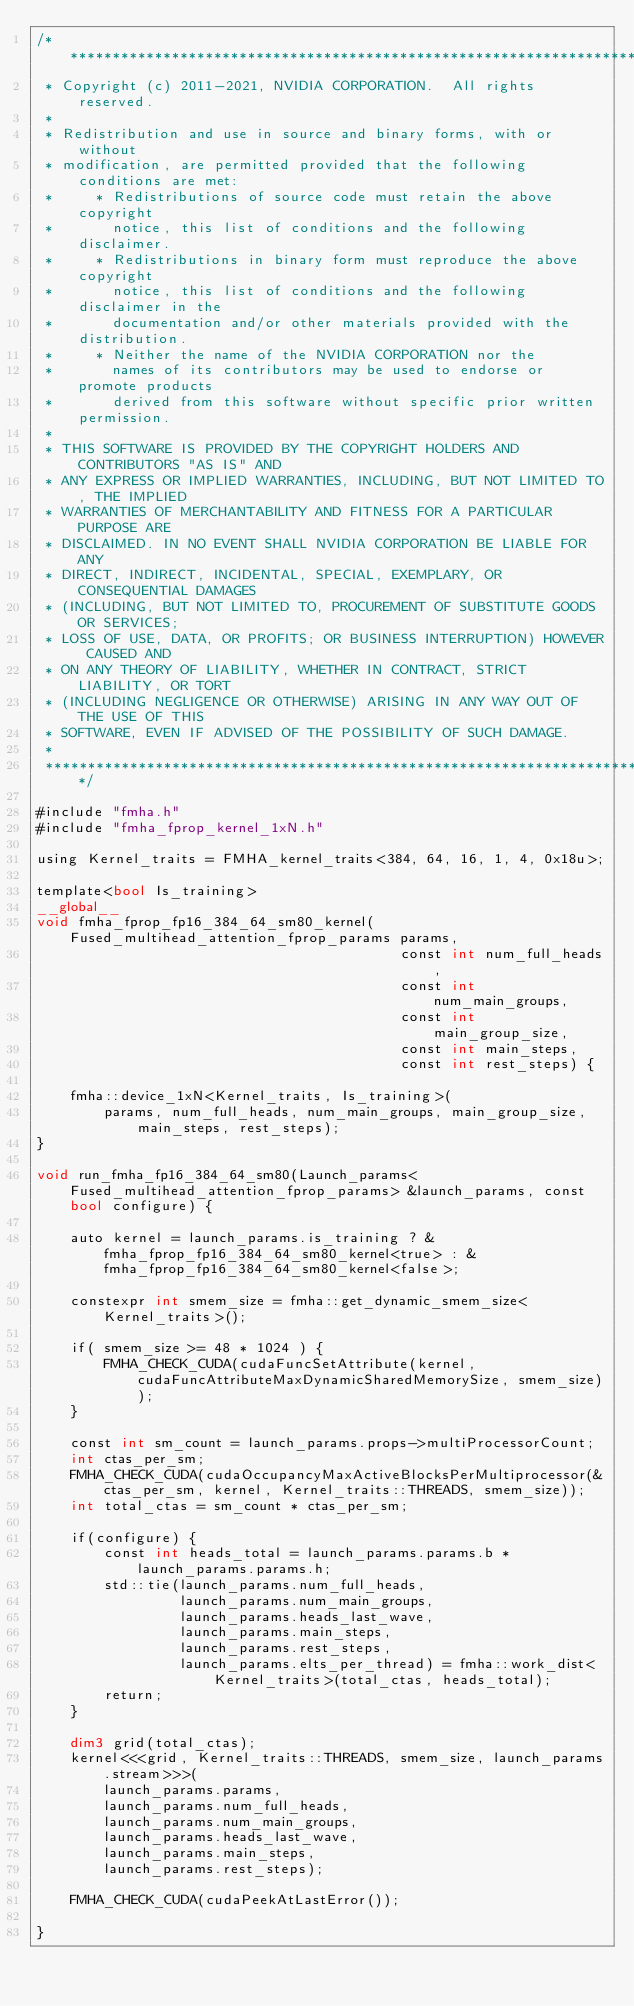Convert code to text. <code><loc_0><loc_0><loc_500><loc_500><_Cuda_>/******************************************************************************
 * Copyright (c) 2011-2021, NVIDIA CORPORATION.  All rights reserved.
 * 
 * Redistribution and use in source and binary forms, with or without
 * modification, are permitted provided that the following conditions are met:
 *     * Redistributions of source code must retain the above copyright
 *       notice, this list of conditions and the following disclaimer.
 *     * Redistributions in binary form must reproduce the above copyright
 *       notice, this list of conditions and the following disclaimer in the
 *       documentation and/or other materials provided with the distribution.
 *     * Neither the name of the NVIDIA CORPORATION nor the
 *       names of its contributors may be used to endorse or promote products
 *       derived from this software without specific prior written permission.
 * 
 * THIS SOFTWARE IS PROVIDED BY THE COPYRIGHT HOLDERS AND CONTRIBUTORS "AS IS" AND
 * ANY EXPRESS OR IMPLIED WARRANTIES, INCLUDING, BUT NOT LIMITED TO, THE IMPLIED
 * WARRANTIES OF MERCHANTABILITY AND FITNESS FOR A PARTICULAR PURPOSE ARE
 * DISCLAIMED. IN NO EVENT SHALL NVIDIA CORPORATION BE LIABLE FOR ANY
 * DIRECT, INDIRECT, INCIDENTAL, SPECIAL, EXEMPLARY, OR CONSEQUENTIAL DAMAGES
 * (INCLUDING, BUT NOT LIMITED TO, PROCUREMENT OF SUBSTITUTE GOODS OR SERVICES;
 * LOSS OF USE, DATA, OR PROFITS; OR BUSINESS INTERRUPTION) HOWEVER CAUSED AND
 * ON ANY THEORY OF LIABILITY, WHETHER IN CONTRACT, STRICT LIABILITY, OR TORT
 * (INCLUDING NEGLIGENCE OR OTHERWISE) ARISING IN ANY WAY OUT OF THE USE OF THIS
 * SOFTWARE, EVEN IF ADVISED OF THE POSSIBILITY OF SUCH DAMAGE.
 *
 ******************************************************************************/

#include "fmha.h"
#include "fmha_fprop_kernel_1xN.h"

using Kernel_traits = FMHA_kernel_traits<384, 64, 16, 1, 4, 0x18u>;

template<bool Is_training>
__global__ 
void fmha_fprop_fp16_384_64_sm80_kernel(Fused_multihead_attention_fprop_params params,
                                           const int num_full_heads,
                                           const int num_main_groups,
                                           const int main_group_size,
                                           const int main_steps,
                                           const int rest_steps) {

    fmha::device_1xN<Kernel_traits, Is_training>(
        params, num_full_heads, num_main_groups, main_group_size, main_steps, rest_steps);
}

void run_fmha_fp16_384_64_sm80(Launch_params<Fused_multihead_attention_fprop_params> &launch_params, const bool configure) {

    auto kernel = launch_params.is_training ? &fmha_fprop_fp16_384_64_sm80_kernel<true> : &fmha_fprop_fp16_384_64_sm80_kernel<false>;

    constexpr int smem_size = fmha::get_dynamic_smem_size<Kernel_traits>();

    if( smem_size >= 48 * 1024 ) {
        FMHA_CHECK_CUDA(cudaFuncSetAttribute(kernel, cudaFuncAttributeMaxDynamicSharedMemorySize, smem_size));
    }

    const int sm_count = launch_params.props->multiProcessorCount;
    int ctas_per_sm;
    FMHA_CHECK_CUDA(cudaOccupancyMaxActiveBlocksPerMultiprocessor(&ctas_per_sm, kernel, Kernel_traits::THREADS, smem_size));
    int total_ctas = sm_count * ctas_per_sm;

    if(configure) {
        const int heads_total = launch_params.params.b * launch_params.params.h;
        std::tie(launch_params.num_full_heads,
                 launch_params.num_main_groups, 
                 launch_params.heads_last_wave, 
                 launch_params.main_steps, 
                 launch_params.rest_steps, 
                 launch_params.elts_per_thread) = fmha::work_dist<Kernel_traits>(total_ctas, heads_total);
        return;
    }

    dim3 grid(total_ctas);
    kernel<<<grid, Kernel_traits::THREADS, smem_size, launch_params.stream>>>(
        launch_params.params,
        launch_params.num_full_heads, 
        launch_params.num_main_groups, 
        launch_params.heads_last_wave, 
        launch_params.main_steps, 
        launch_params.rest_steps);

    FMHA_CHECK_CUDA(cudaPeekAtLastError());

}

</code> 